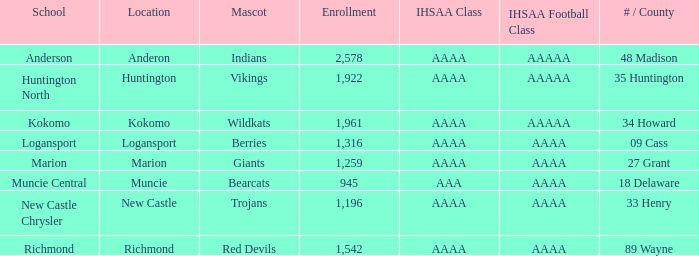What is the ihsaa category of the red devils? AAAA. Could you parse the entire table? {'header': ['School', 'Location', 'Mascot', 'Enrollment', 'IHSAA Class', 'IHSAA Football Class', '# / County'], 'rows': [['Anderson', 'Anderon', 'Indians', '2,578', 'AAAA', 'AAAAA', '48 Madison'], ['Huntington North', 'Huntington', 'Vikings', '1,922', 'AAAA', 'AAAAA', '35 Huntington'], ['Kokomo', 'Kokomo', 'Wildkats', '1,961', 'AAAA', 'AAAAA', '34 Howard'], ['Logansport', 'Logansport', 'Berries', '1,316', 'AAAA', 'AAAA', '09 Cass'], ['Marion', 'Marion', 'Giants', '1,259', 'AAAA', 'AAAA', '27 Grant'], ['Muncie Central', 'Muncie', 'Bearcats', '945', 'AAA', 'AAAA', '18 Delaware'], ['New Castle Chrysler', 'New Castle', 'Trojans', '1,196', 'AAAA', 'AAAA', '33 Henry'], ['Richmond', 'Richmond', 'Red Devils', '1,542', 'AAAA', 'AAAA', '89 Wayne']]} 